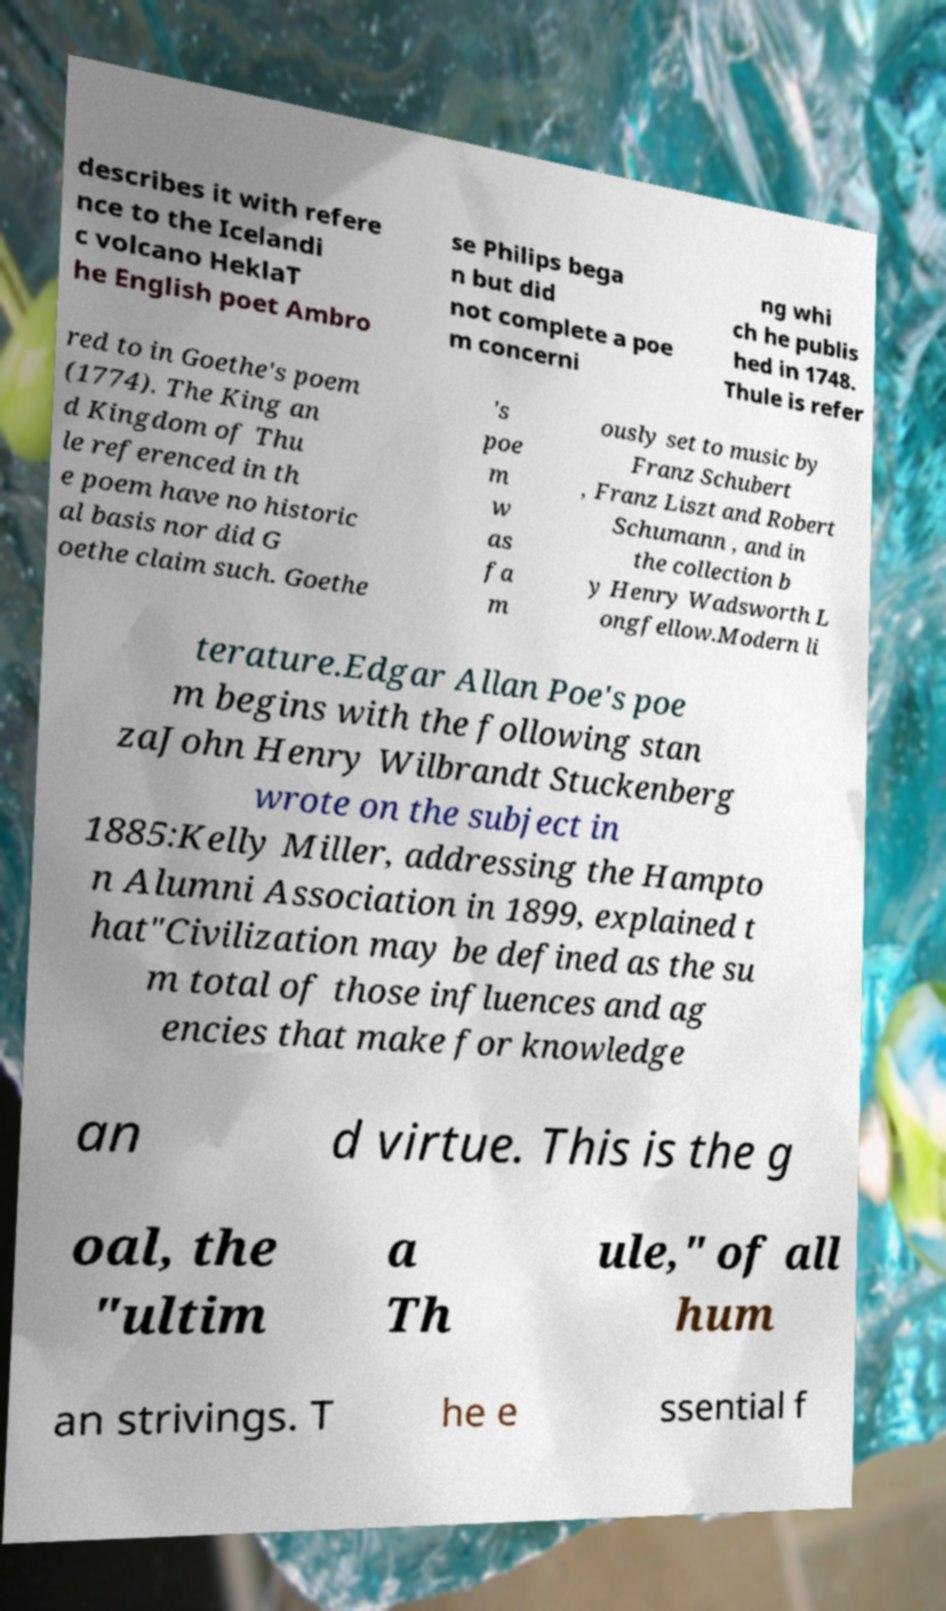For documentation purposes, I need the text within this image transcribed. Could you provide that? describes it with refere nce to the Icelandi c volcano HeklaT he English poet Ambro se Philips bega n but did not complete a poe m concerni ng whi ch he publis hed in 1748. Thule is refer red to in Goethe's poem (1774). The King an d Kingdom of Thu le referenced in th e poem have no historic al basis nor did G oethe claim such. Goethe 's poe m w as fa m ously set to music by Franz Schubert , Franz Liszt and Robert Schumann , and in the collection b y Henry Wadsworth L ongfellow.Modern li terature.Edgar Allan Poe's poe m begins with the following stan zaJohn Henry Wilbrandt Stuckenberg wrote on the subject in 1885:Kelly Miller, addressing the Hampto n Alumni Association in 1899, explained t hat"Civilization may be defined as the su m total of those influences and ag encies that make for knowledge an d virtue. This is the g oal, the "ultim a Th ule," of all hum an strivings. T he e ssential f 